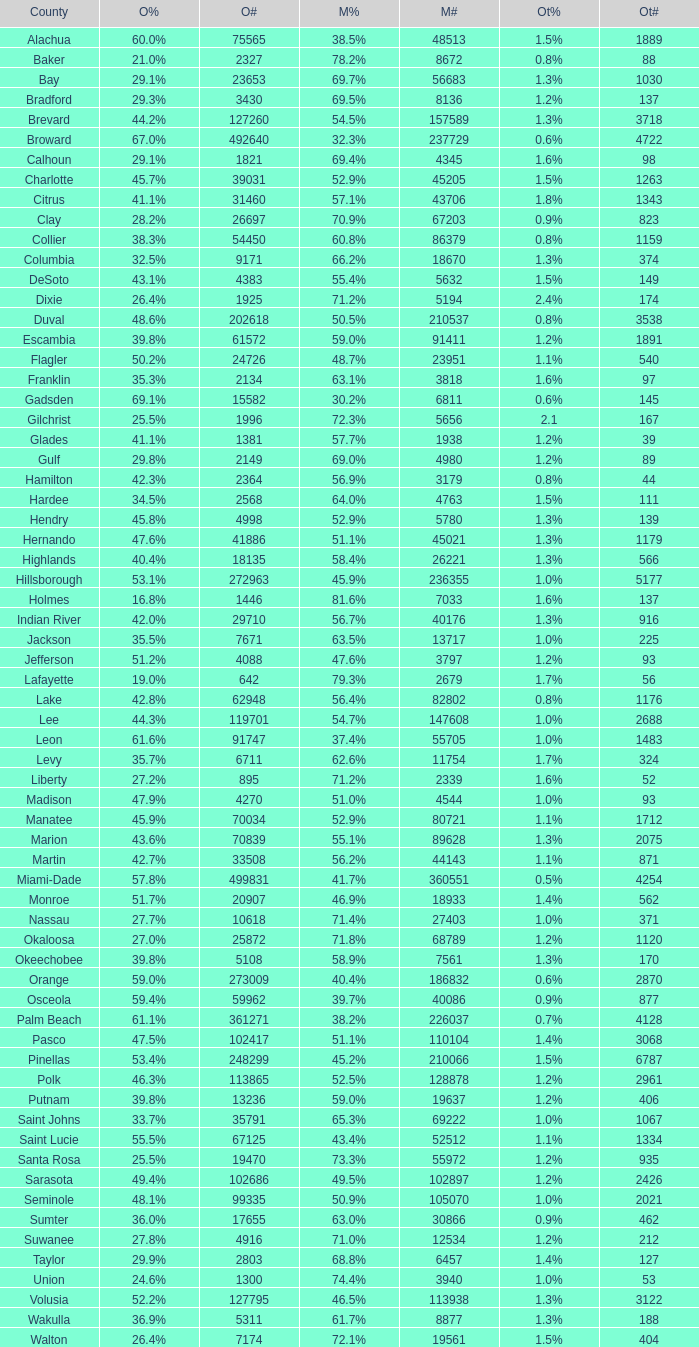How many values were registered under mccain when obama had 2 1.0. 